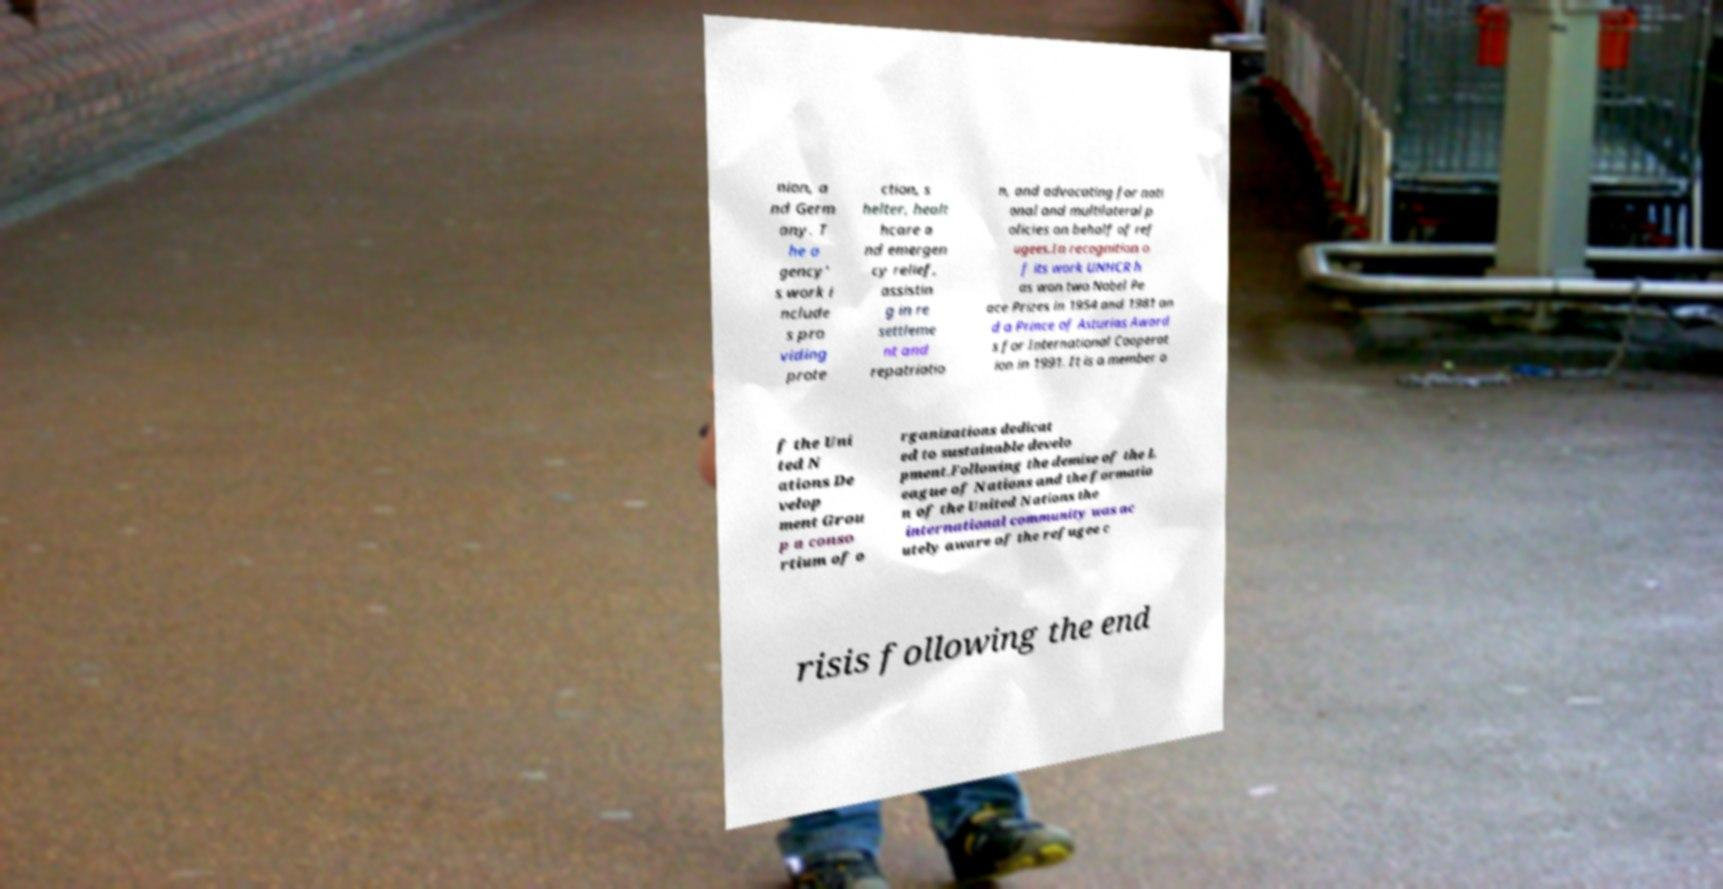Please read and relay the text visible in this image. What does it say? nion, a nd Germ any. T he a gency' s work i nclude s pro viding prote ction, s helter, healt hcare a nd emergen cy relief, assistin g in re settleme nt and repatriatio n, and advocating for nati onal and multilateral p olicies on behalf of ref ugees.In recognition o f its work UNHCR h as won two Nobel Pe ace Prizes in 1954 and 1981 an d a Prince of Asturias Award s for International Cooperat ion in 1991. It is a member o f the Uni ted N ations De velop ment Grou p a conso rtium of o rganizations dedicat ed to sustainable develo pment.Following the demise of the L eague of Nations and the formatio n of the United Nations the international community was ac utely aware of the refugee c risis following the end 